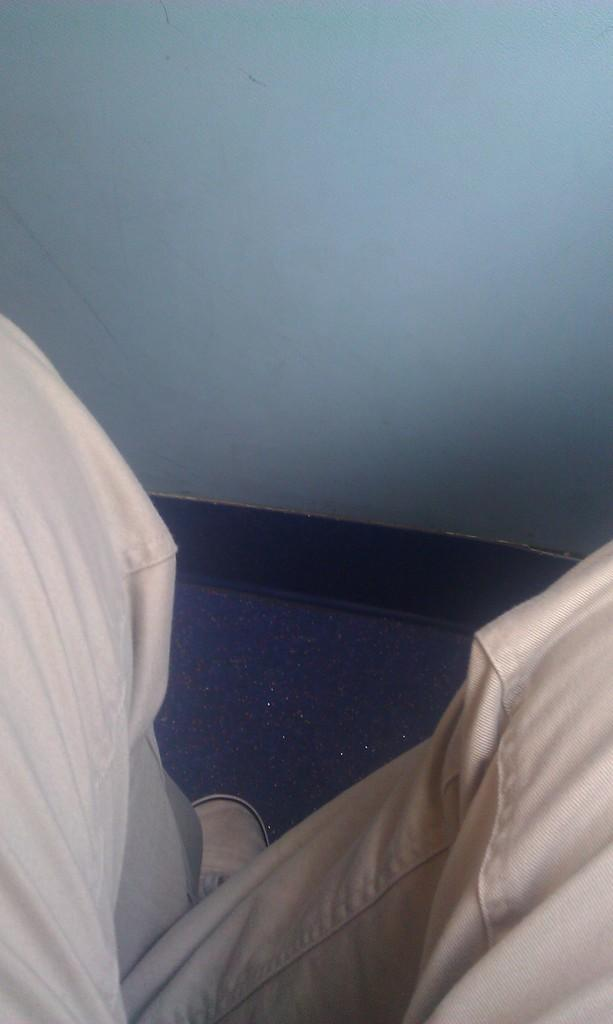What is the main subject in the center of the image? There are human legs in the center of the image. Can you describe any footwear visible in the image? There is one shoe visible in the image. What is visible in the background of the image? There is a wall in the background of the image. What type of kite is being flown by the ant in the image? There is no kite or ant present in the image. How many passengers are visible in the image? There are no passengers visible in the image. 